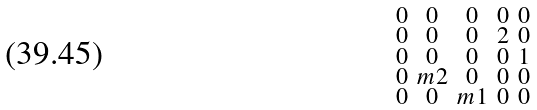Convert formula to latex. <formula><loc_0><loc_0><loc_500><loc_500>\begin{smallmatrix} 0 & 0 & 0 & 0 & 0 \\ 0 & 0 & 0 & 2 & 0 \\ 0 & 0 & 0 & 0 & 1 \\ 0 & m 2 & 0 & 0 & 0 \\ 0 & 0 & m 1 & 0 & 0 \end{smallmatrix}</formula> 